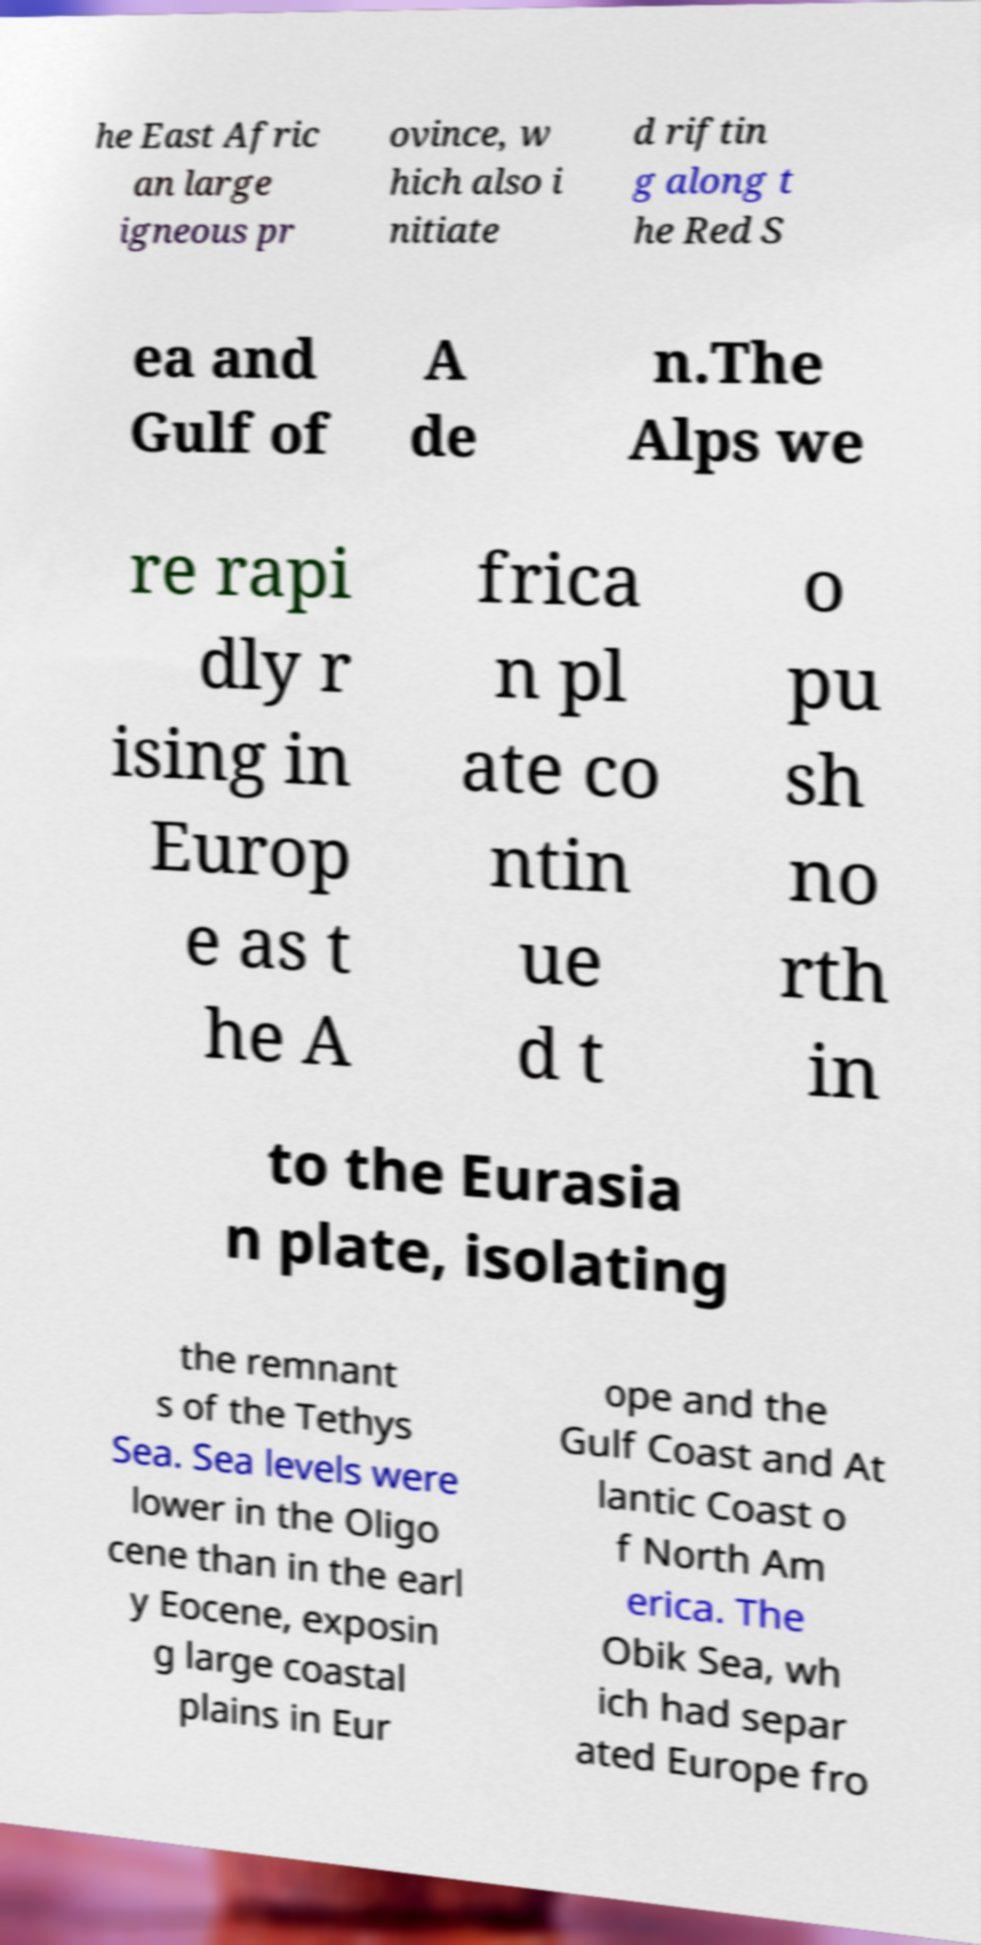I need the written content from this picture converted into text. Can you do that? he East Afric an large igneous pr ovince, w hich also i nitiate d riftin g along t he Red S ea and Gulf of A de n.The Alps we re rapi dly r ising in Europ e as t he A frica n pl ate co ntin ue d t o pu sh no rth in to the Eurasia n plate, isolating the remnant s of the Tethys Sea. Sea levels were lower in the Oligo cene than in the earl y Eocene, exposin g large coastal plains in Eur ope and the Gulf Coast and At lantic Coast o f North Am erica. The Obik Sea, wh ich had separ ated Europe fro 